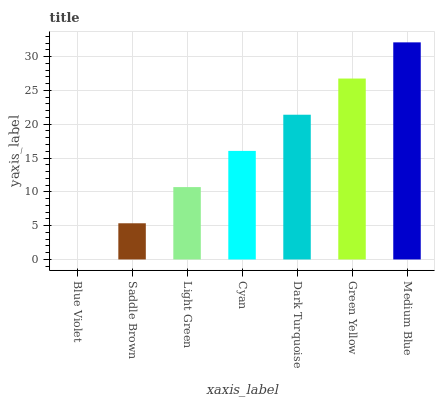Is Blue Violet the minimum?
Answer yes or no. Yes. Is Medium Blue the maximum?
Answer yes or no. Yes. Is Saddle Brown the minimum?
Answer yes or no. No. Is Saddle Brown the maximum?
Answer yes or no. No. Is Saddle Brown greater than Blue Violet?
Answer yes or no. Yes. Is Blue Violet less than Saddle Brown?
Answer yes or no. Yes. Is Blue Violet greater than Saddle Brown?
Answer yes or no. No. Is Saddle Brown less than Blue Violet?
Answer yes or no. No. Is Cyan the high median?
Answer yes or no. Yes. Is Cyan the low median?
Answer yes or no. Yes. Is Medium Blue the high median?
Answer yes or no. No. Is Blue Violet the low median?
Answer yes or no. No. 